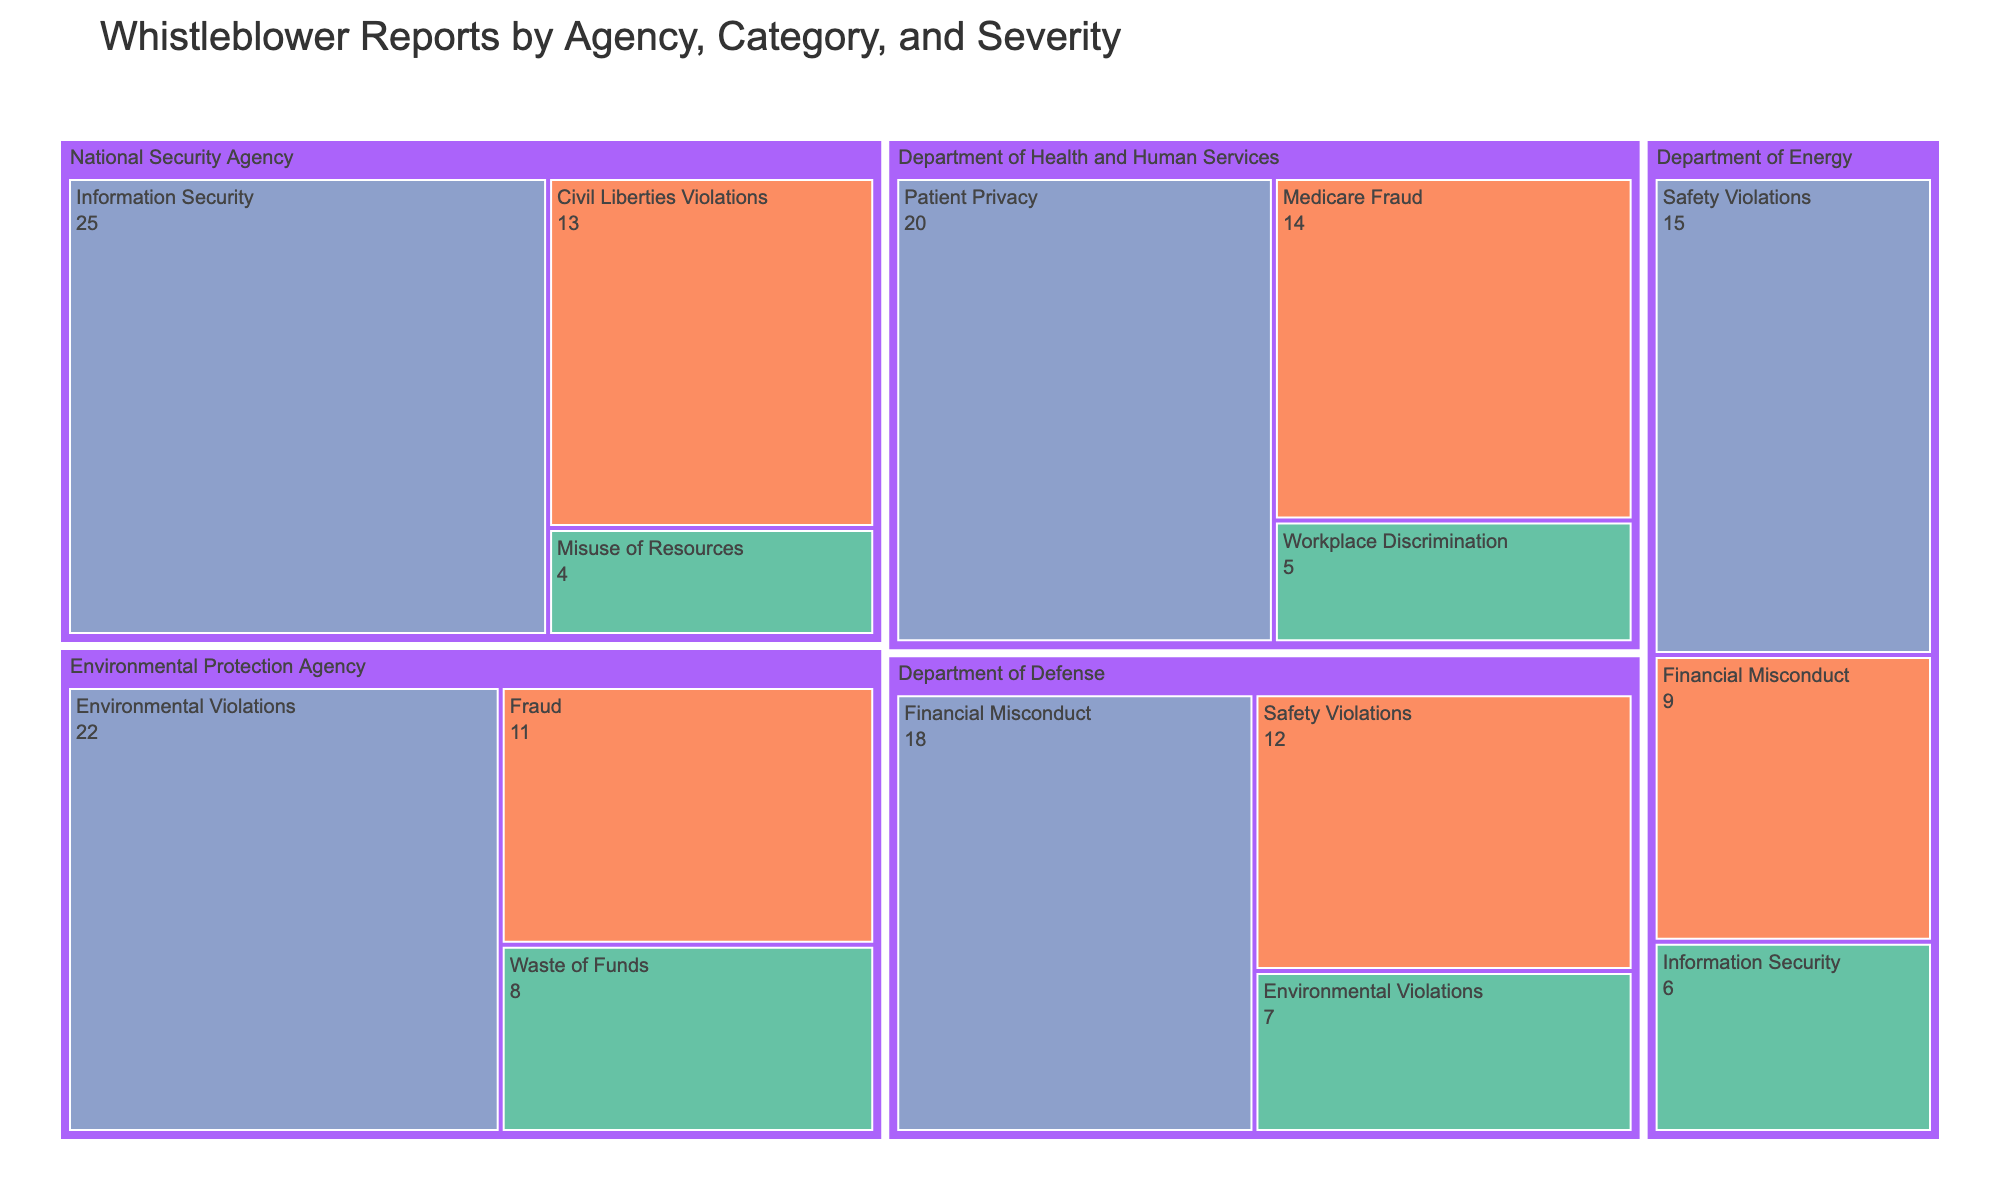Which agency has the highest number of 'Information Security' allegations? By observing the figure, identify the blocks associated with 'Information Security' and compare their sizes. The largest block is for the National Security Agency.
Answer: National Security Agency What are the total number of 'High' severity whistleblower reports across all agencies? Find all the blocks color-coded for 'High' severity, which should be consistent with a specific color, and sum their counts: 18 (Department of Defense) + 15 (Department of Energy) + 22 (Environmental Protection Agency) + 20 (Department of Health and Human Services) + 25 (National Security Agency) = 100
Answer: 100 Which category within the Environmental Protection Agency has the highest severity count? Within the Environmental Protection Agency section, locate all the categories and identify which one has the largest number labeled with 'High' severity, which is 'Environmental Violations' with 22 reports.
Answer: Environmental Violations How many fewer 'Safety Violations' reports are there in the Department of Defense compared to the Department of Energy? Identify and compare the 'Safety Violations' blocks for both agencies: 12 (Department of Defense) and 15 (Department of Energy). Calculate the difference: 15 - 12 = 3.
Answer: 3 Which agency has the smallest number of 'Low' severity reports and what category does it fall under? Look for the smallest area associated with 'Low' severity, which is color-coded uniquely, and identify the agency with the smallest count. The National Security Agency has the smallest count with 'Misuse of Resources' having 4 reports.
Answer: National Security Agency, Misuse of Resources What is the combined total of 'Medium' severity reports for the Department of Health and Human Services? Identify and sum the 'Medium' severity blocks within the Department of Health and Human Services section: 14 + 0 = 14 (Note: Only 'Medicare Fraud' is present with 14.)
Answer: 14 Which category in the Department of Defense has the highest number of whistleblower reports? Look into the Department of Defense section and compare the sizes of the blocks, identifying which one corresponds to the largest count number. 'Financial Misconduct' with 18 reports is the largest.
Answer: Financial Misconduct Is the total number of 'Low' severity reports in the Department of Energy greater than the total number of 'Low' severity reports in the Environmental Protection Agency? Sum the counts for 'Low' severity in each agency: Department of Energy - 6; Environmental Protection Agency - 8. Since 6 is less than 8, the total in the Department of Energy is not greater.
Answer: No Which category under the National Security Agency has the lowest count of whistleblower reports? In the National Security Agency section, compare the sizes of all categories and identify the smallest one, which is 'Misuse of Resources' with 4 reports.
Answer: Misuse of Resources 